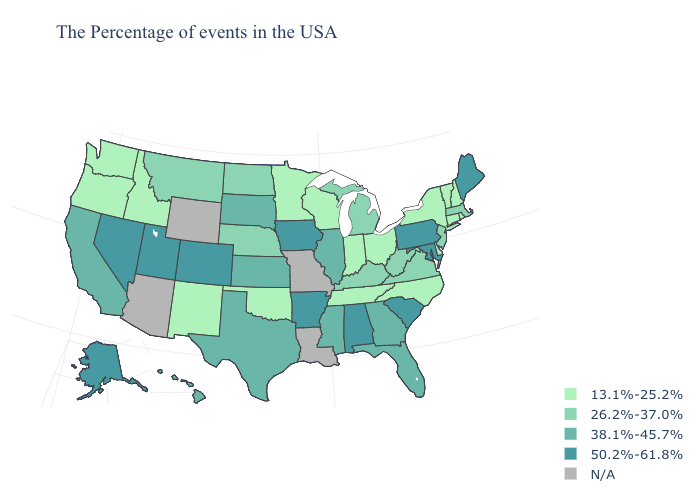Which states have the highest value in the USA?
Concise answer only. Maine, Maryland, Pennsylvania, South Carolina, Alabama, Arkansas, Iowa, Colorado, Utah, Nevada, Alaska. Among the states that border Virginia , which have the highest value?
Short answer required. Maryland. What is the highest value in states that border Colorado?
Be succinct. 50.2%-61.8%. Name the states that have a value in the range 38.1%-45.7%?
Concise answer only. Florida, Georgia, Illinois, Mississippi, Kansas, Texas, South Dakota, California, Hawaii. Name the states that have a value in the range 38.1%-45.7%?
Quick response, please. Florida, Georgia, Illinois, Mississippi, Kansas, Texas, South Dakota, California, Hawaii. What is the lowest value in states that border Arkansas?
Be succinct. 13.1%-25.2%. Does Pennsylvania have the highest value in the Northeast?
Quick response, please. Yes. Is the legend a continuous bar?
Write a very short answer. No. Among the states that border Alabama , does Mississippi have the lowest value?
Be succinct. No. What is the highest value in states that border Washington?
Concise answer only. 13.1%-25.2%. Name the states that have a value in the range N/A?
Answer briefly. Louisiana, Missouri, Wyoming, Arizona. What is the lowest value in the MidWest?
Short answer required. 13.1%-25.2%. Does Tennessee have the lowest value in the South?
Short answer required. Yes. Does Alabama have the highest value in the South?
Give a very brief answer. Yes. 